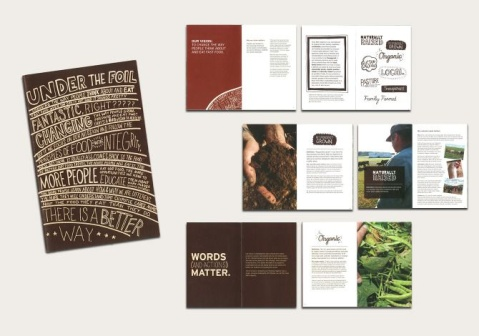Can you tell more about the phrase 'UNDER THE FOIL' featured on one of the materials? The phrase 'UNDER THE FOIL' on the larger material likely serves as a catchphrase or slogan that draws attention to what lies beneath the surface, possibly symbolizing a deeper look into food production techniques. This could be an invitation to explore beyond conventional methods and discover benefits of alternative, perhaps more sustainable, practices in agriculture or food processing. 